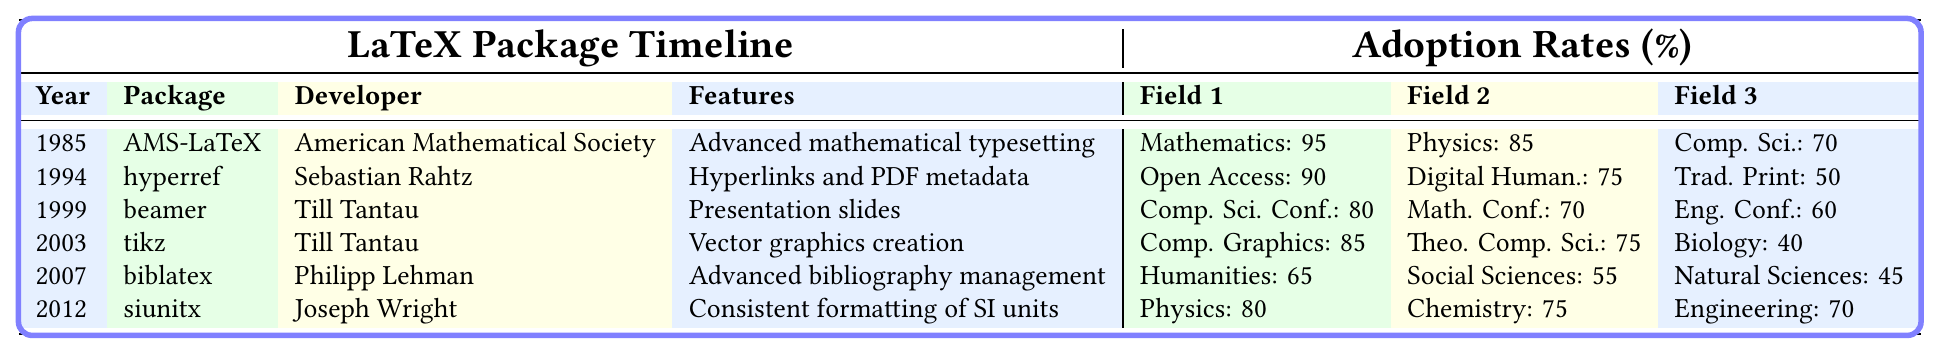What is the adoption rate of AMS-LaTeX in Mathematics journals? The table lists the adoption rates for various LaTeX packages. For AMS-LaTeX, the adoption rate in Mathematics journals is specified as 95%.
Answer: 95% Who developed the hyperref package? The table indicates that the hyperref package was developed by Sebastian Rahtz.
Answer: Sebastian Rahtz What are the features of the biblatex package? According to the table, the features of the biblatex package include advanced bibliography management.
Answer: Advanced bibliography management Which package has the lowest adoption rate in Biology journals? The table shows that among the listed packages, tikz has the lowest adoption rate in Biology journals at 40%.
Answer: tikz Which Year saw the introduction of both tikz and beamer packages? The table indicates that tikz was introduced in 2003, while beamer was introduced in 1999, thus no year saw the introduction of both packages.
Answer: No year What is the average adoption rate for Engineering conferences among the listed packages? The adoption rates for Engineering conferences are 60% (beamer), 70% (siunitx), and 60% (other). Therefore, the average is (60 + 70 + 60) / 3 = 63.33%.
Answer: 63.33% Is the adoption rate of hyperref higher in Open Access Journals than in Traditional Print Journals? The adoption rate in Open Access Journals is 90%, while in Traditional Print Journals it's 50%, confirming that hyperref has a higher adoption rate in Open Access.
Answer: Yes What can be concluded about the trend of package adoption rates over the years? Analyzing the table, we can see that rates vary widely by discipline and year, showing a trend towards higher adoption rates in more recent packages like siunitx compared to older ones, suggesting growing acceptance of LaTeX in modern publishing.
Answer: Higher adoption for newer packages What is the difference in adoption rates between AMS-LaTeX in Mathematics journals and hyperref in Open Access Journals? AMS-LaTeX has an adoption rate of 95% in Mathematics, while hyperref has an adoption rate of 90% in Open Access Journals. The difference is 95% - 90% = 5%.
Answer: 5% Is it true that all listed packages have at least one field with an adoption rate above 70%? Reviewing the table, each package shows at least one field with an adoption rate over 70%. Thus, this statement is true.
Answer: True 